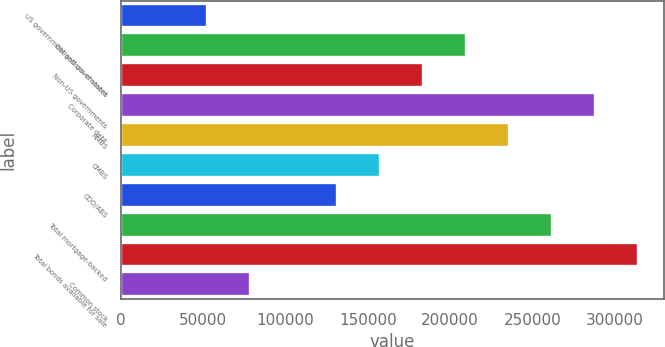Convert chart to OTSL. <chart><loc_0><loc_0><loc_500><loc_500><bar_chart><fcel>US government and government<fcel>Obligations of states<fcel>Non-US governments<fcel>Corporate debt<fcel>RMBS<fcel>CMBS<fcel>CDO/ABS<fcel>Total mortgage-backed<fcel>Total bonds available for sale<fcel>Common stock<nl><fcel>52407.6<fcel>209549<fcel>183359<fcel>288120<fcel>235740<fcel>157169<fcel>130978<fcel>261930<fcel>314311<fcel>78597.9<nl></chart> 